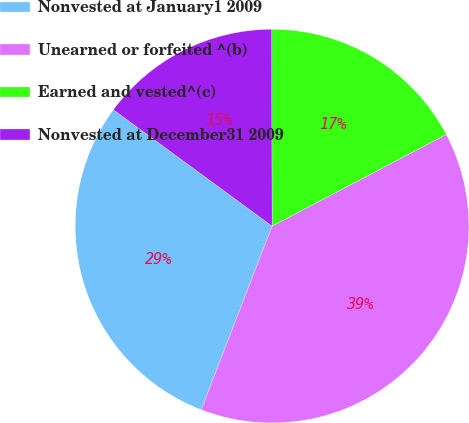<chart> <loc_0><loc_0><loc_500><loc_500><pie_chart><fcel>Nonvested at January1 2009<fcel>Unearned or forfeited ^(b)<fcel>Earned and vested^(c)<fcel>Nonvested at December31 2009<nl><fcel>29.21%<fcel>38.57%<fcel>17.32%<fcel>14.9%<nl></chart> 